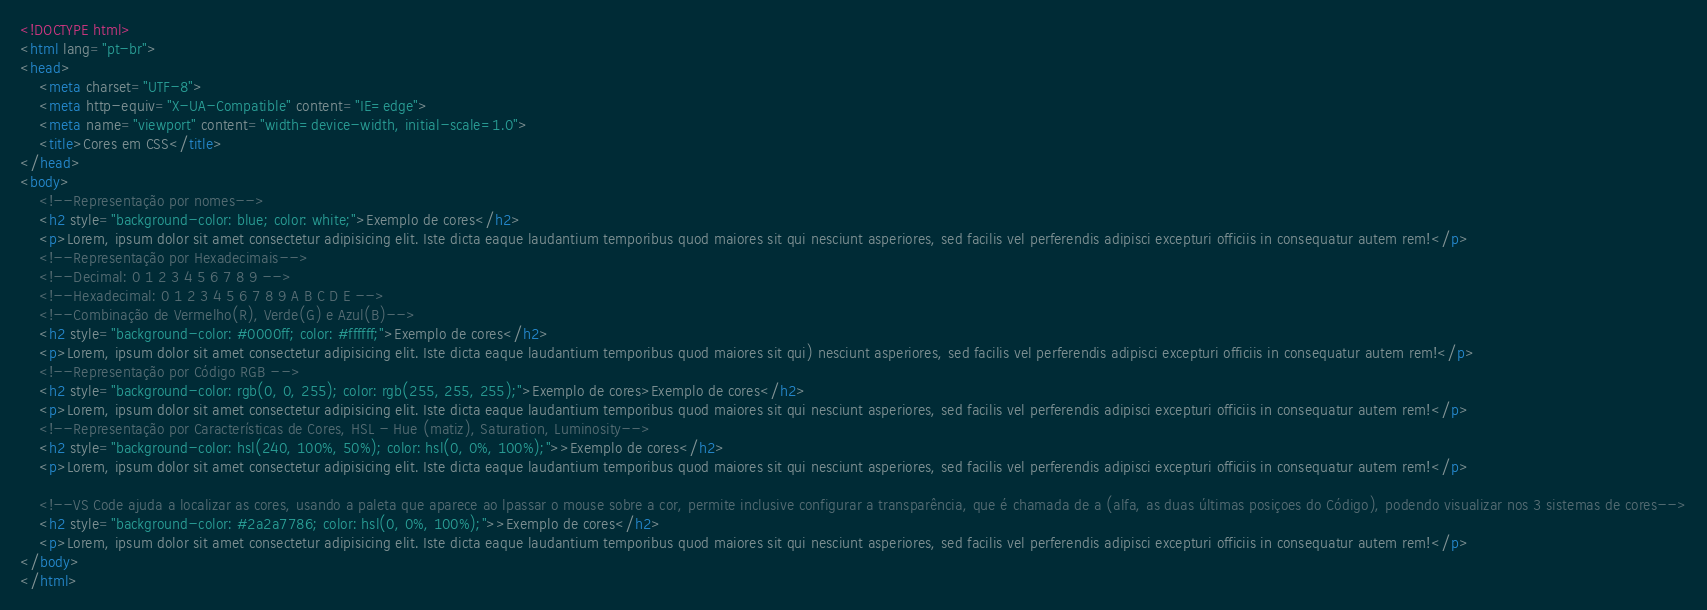<code> <loc_0><loc_0><loc_500><loc_500><_HTML_><!DOCTYPE html>
<html lang="pt-br">
<head>
    <meta charset="UTF-8">
    <meta http-equiv="X-UA-Compatible" content="IE=edge">
    <meta name="viewport" content="width=device-width, initial-scale=1.0">
    <title>Cores em CSS</title>
</head>
<body>
    <!--Representação por nomes-->
    <h2 style="background-color: blue; color: white;">Exemplo de cores</h2>
    <p>Lorem, ipsum dolor sit amet consectetur adipisicing elit. Iste dicta eaque laudantium temporibus quod maiores sit qui nesciunt asperiores, sed facilis vel perferendis adipisci excepturi officiis in consequatur autem rem!</p>
    <!--Representação por Hexadecimais-->
    <!--Decimal: 0 1 2 3 4 5 6 7 8 9 -->
    <!--Hexadecimal: 0 1 2 3 4 5 6 7 8 9 A B C D E -->
    <!--Combinação de Vermelho(R), Verde(G) e Azul(B)-->
    <h2 style="background-color: #0000ff; color: #ffffff;">Exemplo de cores</h2>
    <p>Lorem, ipsum dolor sit amet consectetur adipisicing elit. Iste dicta eaque laudantium temporibus quod maiores sit qui) nesciunt asperiores, sed facilis vel perferendis adipisci excepturi officiis in consequatur autem rem!</p>
    <!--Representação por Código RGB -->
    <h2 style="background-color: rgb(0, 0, 255); color: rgb(255, 255, 255);">Exemplo de cores>Exemplo de cores</h2>
    <p>Lorem, ipsum dolor sit amet consectetur adipisicing elit. Iste dicta eaque laudantium temporibus quod maiores sit qui nesciunt asperiores, sed facilis vel perferendis adipisci excepturi officiis in consequatur autem rem!</p>
    <!--Representação por Características de Cores, HSL - Hue (matiz), Saturation, Luminosity-->
    <h2 style="background-color: hsl(240, 100%, 50%); color: hsl(0, 0%, 100%);">>Exemplo de cores</h2>
    <p>Lorem, ipsum dolor sit amet consectetur adipisicing elit. Iste dicta eaque laudantium temporibus quod maiores sit qui nesciunt asperiores, sed facilis vel perferendis adipisci excepturi officiis in consequatur autem rem!</p>

    <!--VS Code ajuda a localizar as cores, usando a paleta que aparece ao lpassar o mouse sobre a cor, permite inclusive configurar a transparência, que é chamada de a (alfa, as duas últimas posiçoes do Código), podendo visualizar nos 3 sistemas de cores-->
    <h2 style="background-color: #2a2a7786; color: hsl(0, 0%, 100%);">>Exemplo de cores</h2>
    <p>Lorem, ipsum dolor sit amet consectetur adipisicing elit. Iste dicta eaque laudantium temporibus quod maiores sit qui nesciunt asperiores, sed facilis vel perferendis adipisci excepturi officiis in consequatur autem rem!</p>
</body>
</html></code> 